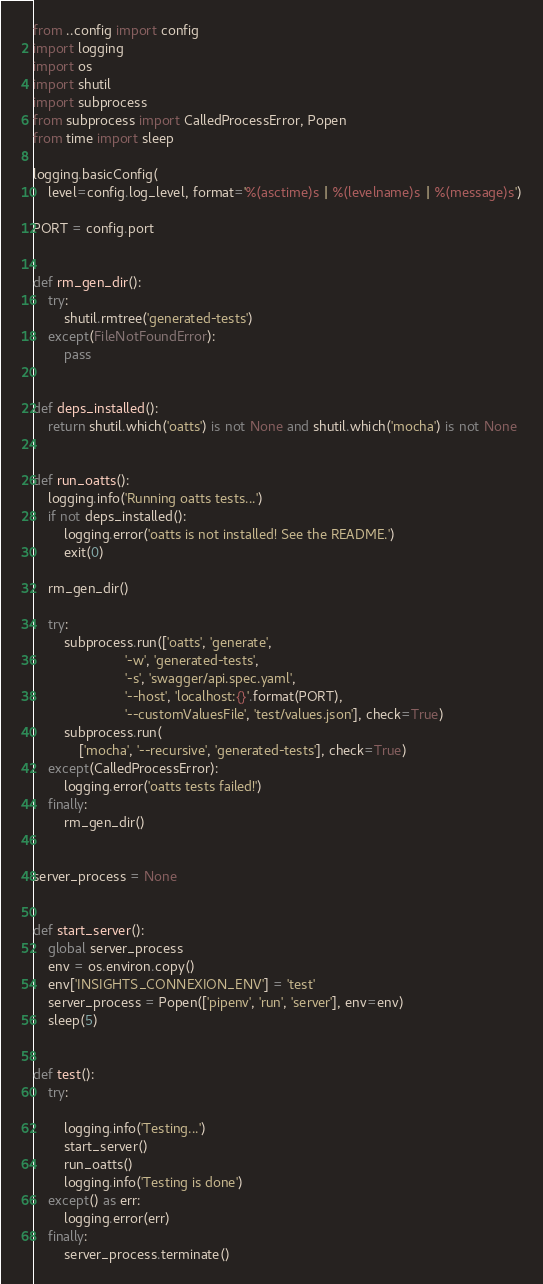Convert code to text. <code><loc_0><loc_0><loc_500><loc_500><_Python_>from ..config import config
import logging
import os
import shutil
import subprocess
from subprocess import CalledProcessError, Popen
from time import sleep

logging.basicConfig(
    level=config.log_level, format='%(asctime)s | %(levelname)s | %(message)s')

PORT = config.port


def rm_gen_dir():
    try:
        shutil.rmtree('generated-tests')
    except(FileNotFoundError):
        pass


def deps_installed():
    return shutil.which('oatts') is not None and shutil.which('mocha') is not None


def run_oatts():
    logging.info('Running oatts tests...')
    if not deps_installed():
        logging.error('oatts is not installed! See the README.')
        exit(0)

    rm_gen_dir()

    try:
        subprocess.run(['oatts', 'generate',
                        '-w', 'generated-tests',
                        '-s', 'swagger/api.spec.yaml',
                        '--host', 'localhost:{}'.format(PORT),
                        '--customValuesFile', 'test/values.json'], check=True)
        subprocess.run(
            ['mocha', '--recursive', 'generated-tests'], check=True)
    except(CalledProcessError):
        logging.error('oatts tests failed!')
    finally:
        rm_gen_dir()


server_process = None


def start_server():
    global server_process
    env = os.environ.copy()
    env['INSIGHTS_CONNEXION_ENV'] = 'test'
    server_process = Popen(['pipenv', 'run', 'server'], env=env)
    sleep(5)


def test():
    try:

        logging.info('Testing...')
        start_server()
        run_oatts()
        logging.info('Testing is done')
    except() as err:
        logging.error(err)
    finally:
        server_process.terminate()
</code> 